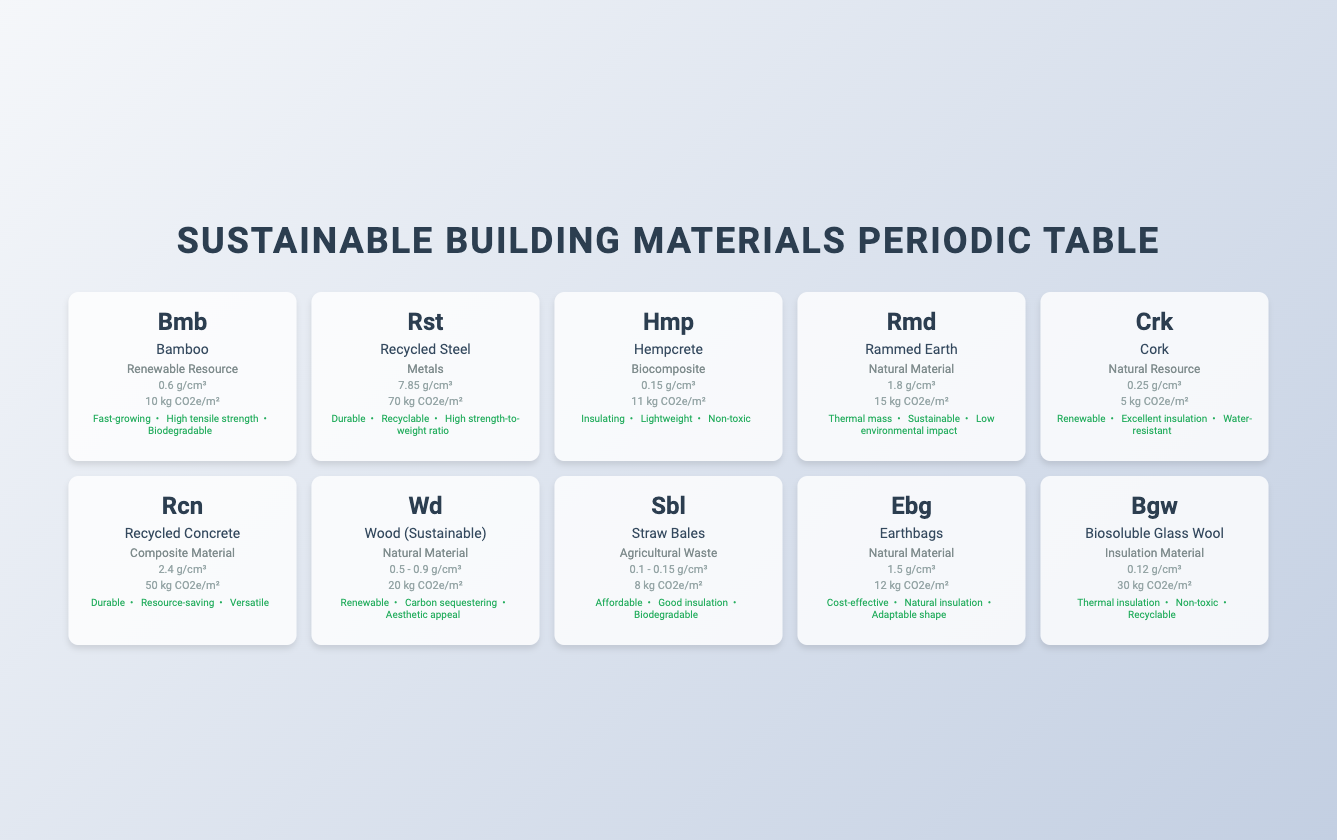What is the carbon footprint of Cork? According to the table, the carbon footprint of Cork is listed as "5 kg CO2e/m²."
Answer: 5 kg CO2e/m² Which material has the highest carbon footprint? By comparing the carbon footprints in the table, Recycled Steel has the highest value at "70 kg CO2e/m²."
Answer: Recycled Steel Is Bamboo biodegradable? The properties listed for Bamboo include "Biodegradable," indicating that it is indeed biodegradable.
Answer: Yes What is the average carbon footprint of all listed materials? The carbon footprints are: 10, 70, 11, 15, 5, 50, 20, 8, 12, 30 (in kg CO2e/m²). Adding these gives 10 + 70 + 11 + 15 + 5 + 50 + 20 + 8 + 12 + 30 = 231. There are 10 materials, so the average is 231/10 = 23.1.
Answer: 23.1 kg CO2e/m² Is Straw Bales more environmentally friendly than Rammed Earth in terms of carbon footprint? The carbon footprint of Straw Bales is "8 kg CO2e/m²," while Rammed Earth has a footprint of "15 kg CO2e/m²." Since 8 is less than 15, Straw Bales is indeed more environmentally friendly in this regard.
Answer: Yes What two properties do Hempcrete and Earthbags have in common? By examining the properties listed, Hempcrete has "Insulating," "Lightweight," and "Non-toxic," while Earthbags have "Cost-effective," "Natural insulation," and "Adaptable shape." Both materials share the property "Natural insulation," though Hempcrete is marked as "Insulating," which relates to this aspect.
Answer: Natural insulation, Insulating Which material has the least density and what is that density? Looking at the density values, Straw Bales has the least density at "0.1 - 0.15 g/cm³."
Answer: 0.1 - 0.15 g/cm³ If a building uses 100 m² of Recycled Concrete, what would be its total carbon footprint? The carbon footprint for Recycled Concrete is "50 kg CO2e/m²." For 100 m², total carbon footprint would be 100 * 50 = 5000 kg CO2e overall.
Answer: 5000 kg CO2e Which material's density is in the range of 0.5 to 0.9 g/cm³? The material listed with a density range of "0.5 - 0.9 g/cm³" is Wood (Sustainable).
Answer: Wood (Sustainable) 